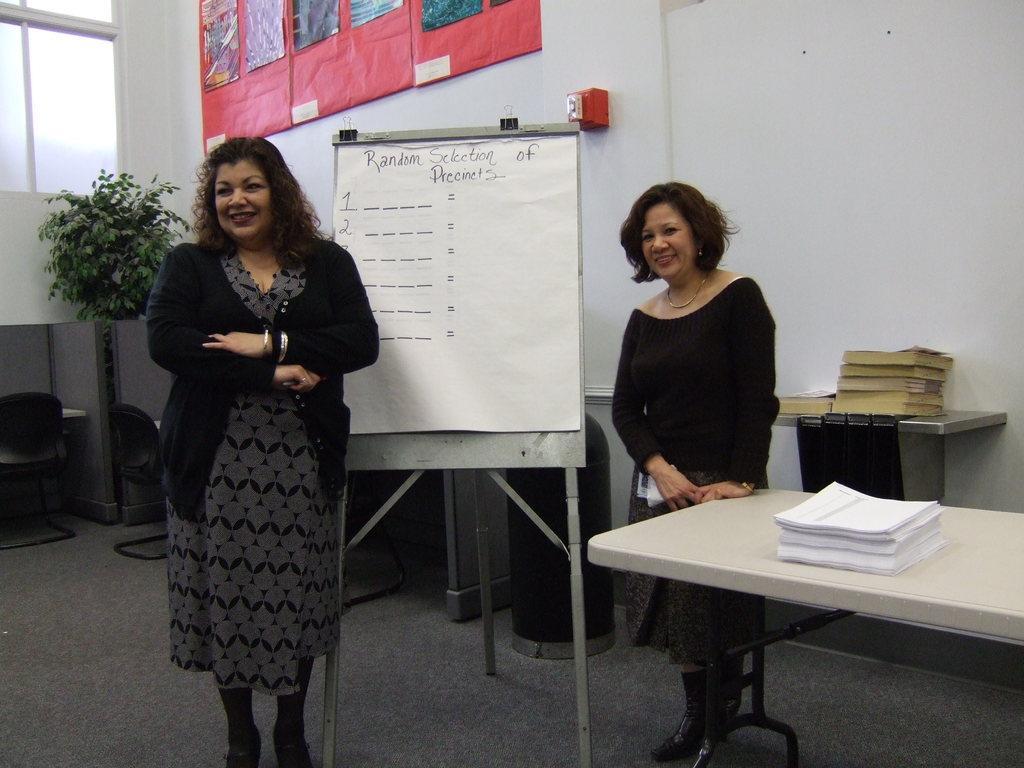Describe this image in one or two sentences. In this Image I see 2 women who are standing and both of them are smiling. I can also see a table over here on which there are lot of papers. In the background I see the board, a plant, few books and there are charts on the wall and a window. 